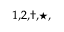Convert formula to latex. <formula><loc_0><loc_0><loc_500><loc_500>^ { 1 , 2 , \dagger , ^ { * } , }</formula> 